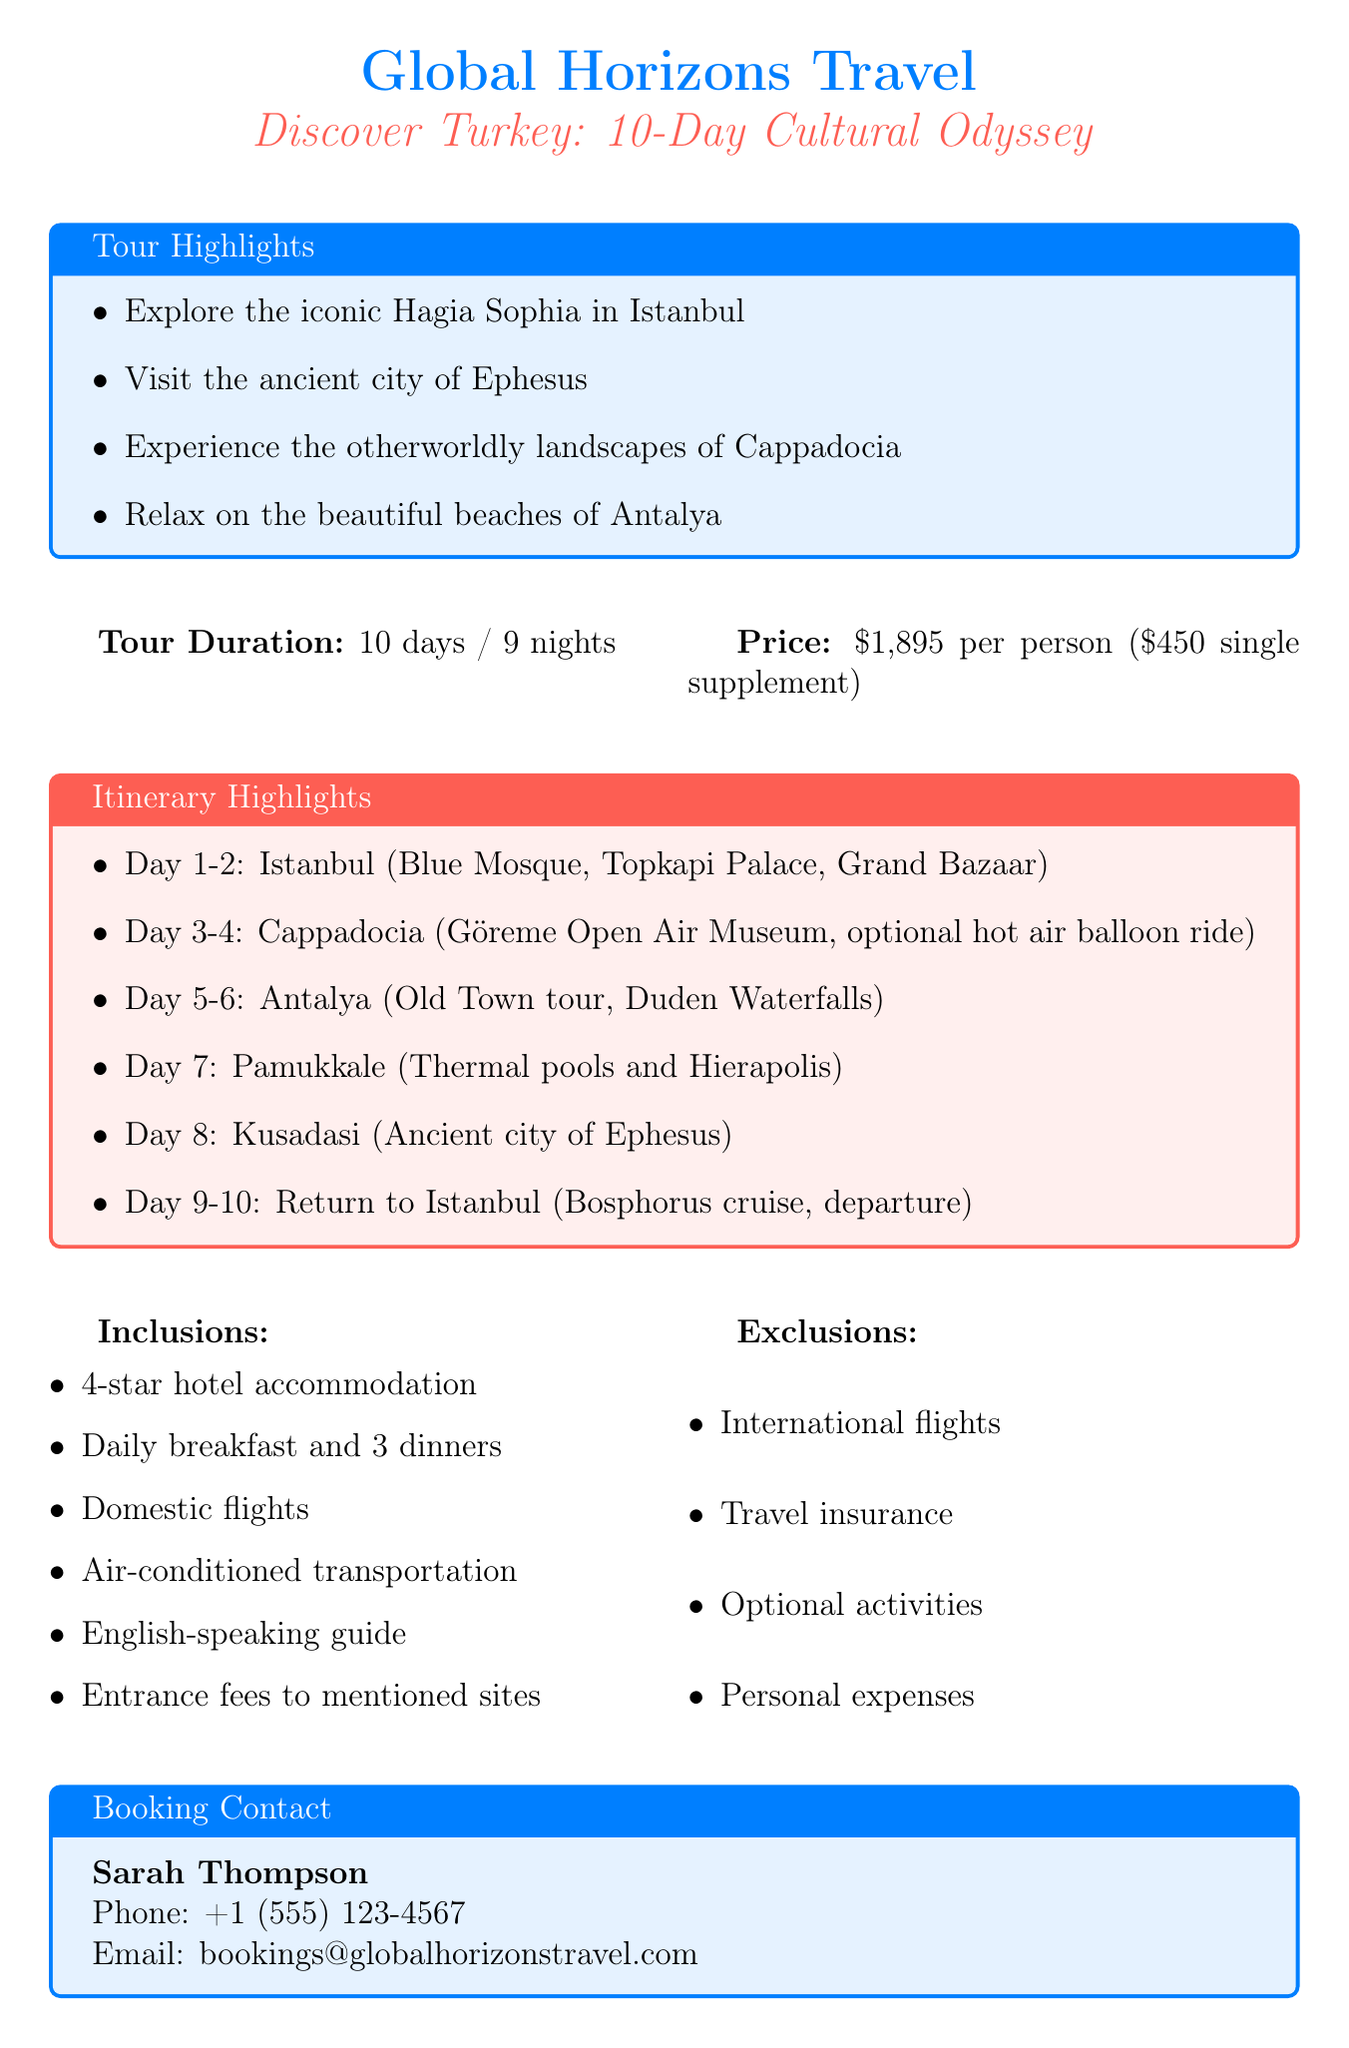What is the name of the travel agency? The document specifies that the travel agency is named Global Horizons Travel.
Answer: Global Horizons Travel What is the duration of the tour? The document states that the tour lasts for 10 days and 9 nights.
Answer: 10 days / 9 nights What is the price per person for the tour? According to the document, the price per person for the tour is $1,895.
Answer: $1,895 Which city will travelers fly into on Day 1? The itinerary indicates that travelers will arrive in Istanbul on Day 1.
Answer: Istanbul What optional activity is mentioned in the tour? The document includes a hot air balloon ride as an optional activity in Cappadocia.
Answer: Hot air balloon ride What is included in the tour package? The document lists several inclusions, such as accommodation in 4-star hotels and daily breakfast.
Answer: Accommodation in 4-star hotels What types of expenses are excluded from the tour? The document notes that international flights and travel insurance are among the excluded expenses.
Answer: International flights Who is the booking contact for the tour? The document provides the name of the booking contact as Sarah Thompson.
Answer: Sarah Thompson How many dinners are included in the tour? The document states that 3 dinners are included in the tour package.
Answer: 3 dinners 